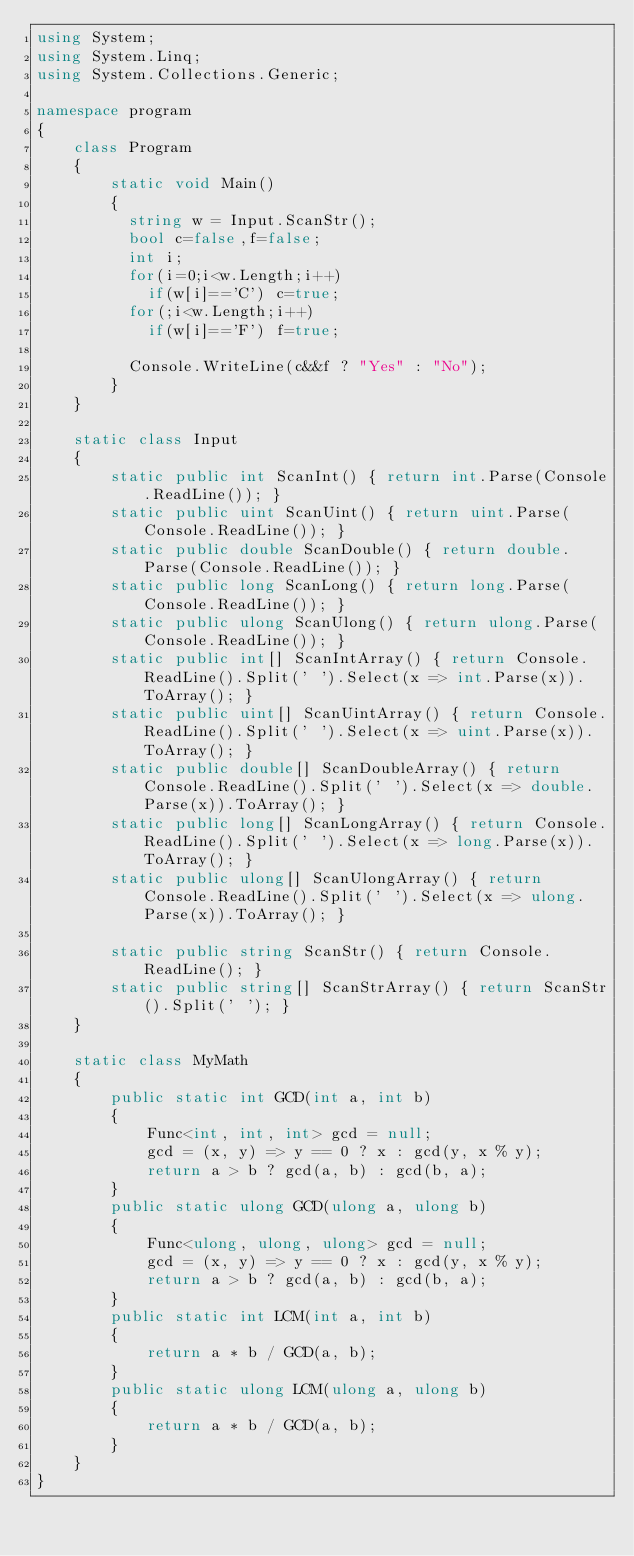Convert code to text. <code><loc_0><loc_0><loc_500><loc_500><_C#_>using System;
using System.Linq;
using System.Collections.Generic;

namespace program
{
    class Program
    {
        static void Main()
        {
          string w = Input.ScanStr();
          bool c=false,f=false;
          int i;
          for(i=0;i<w.Length;i++)
            if(w[i]=='C') c=true;
          for(;i<w.Length;i++)
            if(w[i]=='F') f=true;
          
          Console.WriteLine(c&&f ? "Yes" : "No");
        }
    }

    static class Input
    {
        static public int ScanInt() { return int.Parse(Console.ReadLine()); }
        static public uint ScanUint() { return uint.Parse(Console.ReadLine()); }
        static public double ScanDouble() { return double.Parse(Console.ReadLine()); }
        static public long ScanLong() { return long.Parse(Console.ReadLine()); }
        static public ulong ScanUlong() { return ulong.Parse(Console.ReadLine()); }
        static public int[] ScanIntArray() { return Console.ReadLine().Split(' ').Select(x => int.Parse(x)).ToArray(); }
        static public uint[] ScanUintArray() { return Console.ReadLine().Split(' ').Select(x => uint.Parse(x)).ToArray(); }
        static public double[] ScanDoubleArray() { return Console.ReadLine().Split(' ').Select(x => double.Parse(x)).ToArray(); }
        static public long[] ScanLongArray() { return Console.ReadLine().Split(' ').Select(x => long.Parse(x)).ToArray(); }
        static public ulong[] ScanUlongArray() { return Console.ReadLine().Split(' ').Select(x => ulong.Parse(x)).ToArray(); }

        static public string ScanStr() { return Console.ReadLine(); }
        static public string[] ScanStrArray() { return ScanStr().Split(' '); }
    }

    static class MyMath
    {
        public static int GCD(int a, int b)
        {
            Func<int, int, int> gcd = null;
            gcd = (x, y) => y == 0 ? x : gcd(y, x % y);
            return a > b ? gcd(a, b) : gcd(b, a);
        }
        public static ulong GCD(ulong a, ulong b)
        {
            Func<ulong, ulong, ulong> gcd = null;
            gcd = (x, y) => y == 0 ? x : gcd(y, x % y);
            return a > b ? gcd(a, b) : gcd(b, a);
        }
        public static int LCM(int a, int b)
        {
            return a * b / GCD(a, b);
        }
        public static ulong LCM(ulong a, ulong b)
        {
            return a * b / GCD(a, b);
        }
    }
}
</code> 